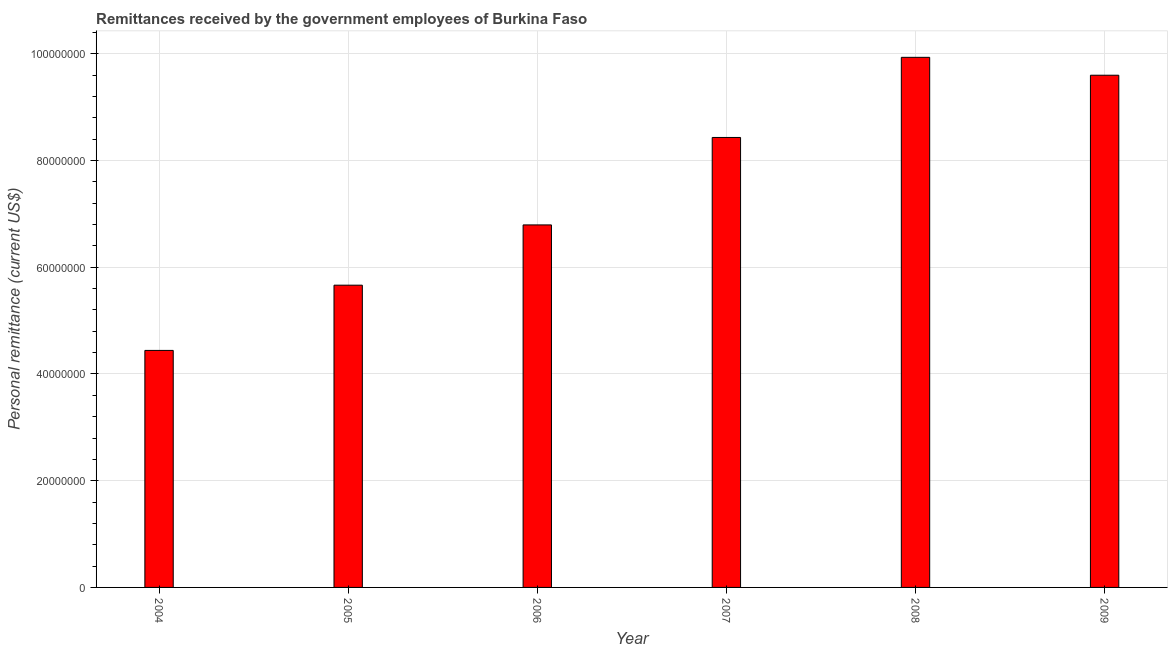What is the title of the graph?
Your response must be concise. Remittances received by the government employees of Burkina Faso. What is the label or title of the X-axis?
Offer a terse response. Year. What is the label or title of the Y-axis?
Your answer should be compact. Personal remittance (current US$). What is the personal remittances in 2008?
Keep it short and to the point. 9.93e+07. Across all years, what is the maximum personal remittances?
Offer a very short reply. 9.93e+07. Across all years, what is the minimum personal remittances?
Provide a succinct answer. 4.44e+07. What is the sum of the personal remittances?
Provide a short and direct response. 4.49e+08. What is the difference between the personal remittances in 2006 and 2008?
Give a very brief answer. -3.14e+07. What is the average personal remittances per year?
Offer a terse response. 7.48e+07. What is the median personal remittances?
Ensure brevity in your answer.  7.61e+07. In how many years, is the personal remittances greater than 12000000 US$?
Provide a succinct answer. 6. Do a majority of the years between 2008 and 2004 (inclusive) have personal remittances greater than 68000000 US$?
Offer a very short reply. Yes. What is the ratio of the personal remittances in 2006 to that in 2007?
Ensure brevity in your answer.  0.81. Is the personal remittances in 2005 less than that in 2009?
Your answer should be very brief. Yes. What is the difference between the highest and the second highest personal remittances?
Your answer should be compact. 3.35e+06. Is the sum of the personal remittances in 2006 and 2008 greater than the maximum personal remittances across all years?
Your answer should be compact. Yes. What is the difference between the highest and the lowest personal remittances?
Give a very brief answer. 5.49e+07. What is the difference between two consecutive major ticks on the Y-axis?
Provide a succinct answer. 2.00e+07. What is the Personal remittance (current US$) of 2004?
Provide a short and direct response. 4.44e+07. What is the Personal remittance (current US$) in 2005?
Make the answer very short. 5.66e+07. What is the Personal remittance (current US$) in 2006?
Offer a very short reply. 6.79e+07. What is the Personal remittance (current US$) in 2007?
Offer a very short reply. 8.43e+07. What is the Personal remittance (current US$) in 2008?
Your response must be concise. 9.93e+07. What is the Personal remittance (current US$) in 2009?
Keep it short and to the point. 9.60e+07. What is the difference between the Personal remittance (current US$) in 2004 and 2005?
Provide a short and direct response. -1.22e+07. What is the difference between the Personal remittance (current US$) in 2004 and 2006?
Offer a very short reply. -2.35e+07. What is the difference between the Personal remittance (current US$) in 2004 and 2007?
Keep it short and to the point. -3.99e+07. What is the difference between the Personal remittance (current US$) in 2004 and 2008?
Keep it short and to the point. -5.49e+07. What is the difference between the Personal remittance (current US$) in 2004 and 2009?
Keep it short and to the point. -5.16e+07. What is the difference between the Personal remittance (current US$) in 2005 and 2006?
Provide a succinct answer. -1.13e+07. What is the difference between the Personal remittance (current US$) in 2005 and 2007?
Your response must be concise. -2.77e+07. What is the difference between the Personal remittance (current US$) in 2005 and 2008?
Make the answer very short. -4.27e+07. What is the difference between the Personal remittance (current US$) in 2005 and 2009?
Provide a succinct answer. -3.93e+07. What is the difference between the Personal remittance (current US$) in 2006 and 2007?
Offer a very short reply. -1.64e+07. What is the difference between the Personal remittance (current US$) in 2006 and 2008?
Provide a succinct answer. -3.14e+07. What is the difference between the Personal remittance (current US$) in 2006 and 2009?
Offer a very short reply. -2.81e+07. What is the difference between the Personal remittance (current US$) in 2007 and 2008?
Your answer should be very brief. -1.50e+07. What is the difference between the Personal remittance (current US$) in 2007 and 2009?
Make the answer very short. -1.17e+07. What is the difference between the Personal remittance (current US$) in 2008 and 2009?
Ensure brevity in your answer.  3.35e+06. What is the ratio of the Personal remittance (current US$) in 2004 to that in 2005?
Offer a terse response. 0.78. What is the ratio of the Personal remittance (current US$) in 2004 to that in 2006?
Give a very brief answer. 0.65. What is the ratio of the Personal remittance (current US$) in 2004 to that in 2007?
Offer a very short reply. 0.53. What is the ratio of the Personal remittance (current US$) in 2004 to that in 2008?
Your answer should be very brief. 0.45. What is the ratio of the Personal remittance (current US$) in 2004 to that in 2009?
Provide a succinct answer. 0.46. What is the ratio of the Personal remittance (current US$) in 2005 to that in 2006?
Give a very brief answer. 0.83. What is the ratio of the Personal remittance (current US$) in 2005 to that in 2007?
Give a very brief answer. 0.67. What is the ratio of the Personal remittance (current US$) in 2005 to that in 2008?
Give a very brief answer. 0.57. What is the ratio of the Personal remittance (current US$) in 2005 to that in 2009?
Your answer should be very brief. 0.59. What is the ratio of the Personal remittance (current US$) in 2006 to that in 2007?
Keep it short and to the point. 0.81. What is the ratio of the Personal remittance (current US$) in 2006 to that in 2008?
Offer a terse response. 0.68. What is the ratio of the Personal remittance (current US$) in 2006 to that in 2009?
Offer a very short reply. 0.71. What is the ratio of the Personal remittance (current US$) in 2007 to that in 2008?
Offer a terse response. 0.85. What is the ratio of the Personal remittance (current US$) in 2007 to that in 2009?
Make the answer very short. 0.88. What is the ratio of the Personal remittance (current US$) in 2008 to that in 2009?
Your answer should be compact. 1.03. 